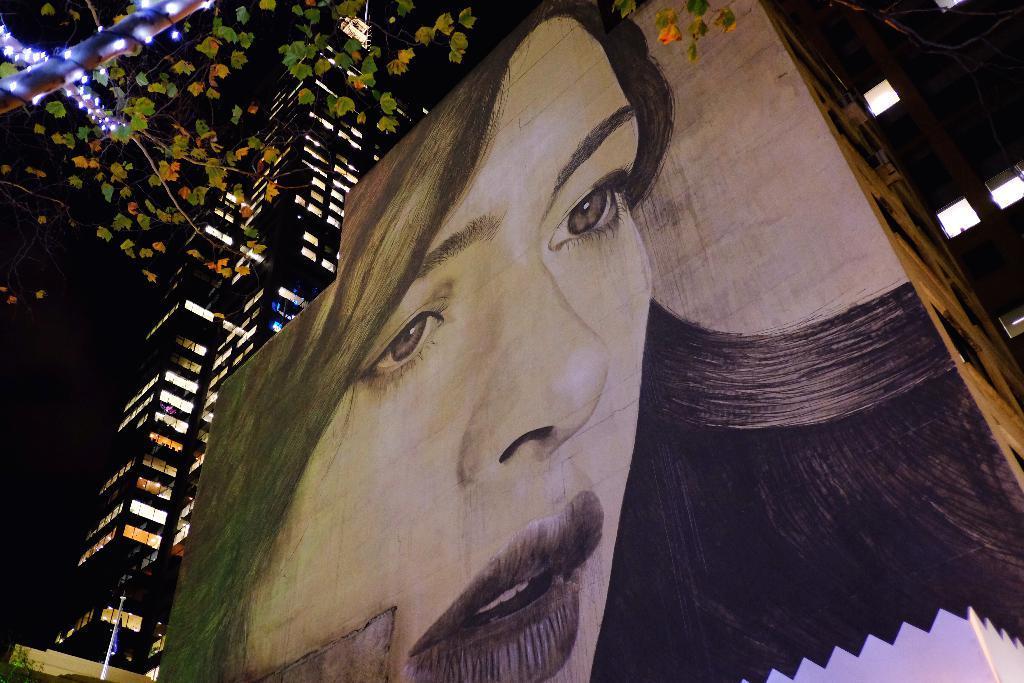In one or two sentences, can you explain what this image depicts? In this picture there is a painting of a woman on the building and there is another building beside it and there is a tree decorated with lights in the left top corner. 